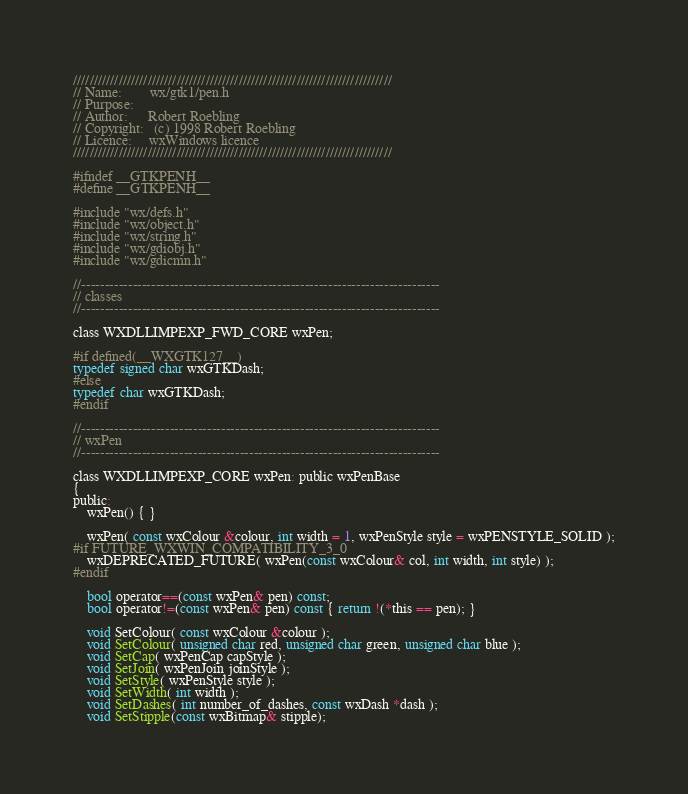Convert code to text. <code><loc_0><loc_0><loc_500><loc_500><_C_>/////////////////////////////////////////////////////////////////////////////
// Name:        wx/gtk1/pen.h
// Purpose:
// Author:      Robert Roebling
// Copyright:   (c) 1998 Robert Roebling
// Licence:     wxWindows licence
/////////////////////////////////////////////////////////////////////////////

#ifndef __GTKPENH__
#define __GTKPENH__

#include "wx/defs.h"
#include "wx/object.h"
#include "wx/string.h"
#include "wx/gdiobj.h"
#include "wx/gdicmn.h"

//-----------------------------------------------------------------------------
// classes
//-----------------------------------------------------------------------------

class WXDLLIMPEXP_FWD_CORE wxPen;

#if defined(__WXGTK127__)
typedef signed char wxGTKDash;
#else
typedef char wxGTKDash;
#endif

//-----------------------------------------------------------------------------
// wxPen
//-----------------------------------------------------------------------------

class WXDLLIMPEXP_CORE wxPen: public wxPenBase
{
public:
    wxPen() { }

    wxPen( const wxColour &colour, int width = 1, wxPenStyle style = wxPENSTYLE_SOLID );
#if FUTURE_WXWIN_COMPATIBILITY_3_0
    wxDEPRECATED_FUTURE( wxPen(const wxColour& col, int width, int style) );
#endif

    bool operator==(const wxPen& pen) const;
    bool operator!=(const wxPen& pen) const { return !(*this == pen); }

    void SetColour( const wxColour &colour );
    void SetColour( unsigned char red, unsigned char green, unsigned char blue );
    void SetCap( wxPenCap capStyle );
    void SetJoin( wxPenJoin joinStyle );
    void SetStyle( wxPenStyle style );
    void SetWidth( int width );
    void SetDashes( int number_of_dashes, const wxDash *dash );
    void SetStipple(const wxBitmap& stipple);
</code> 